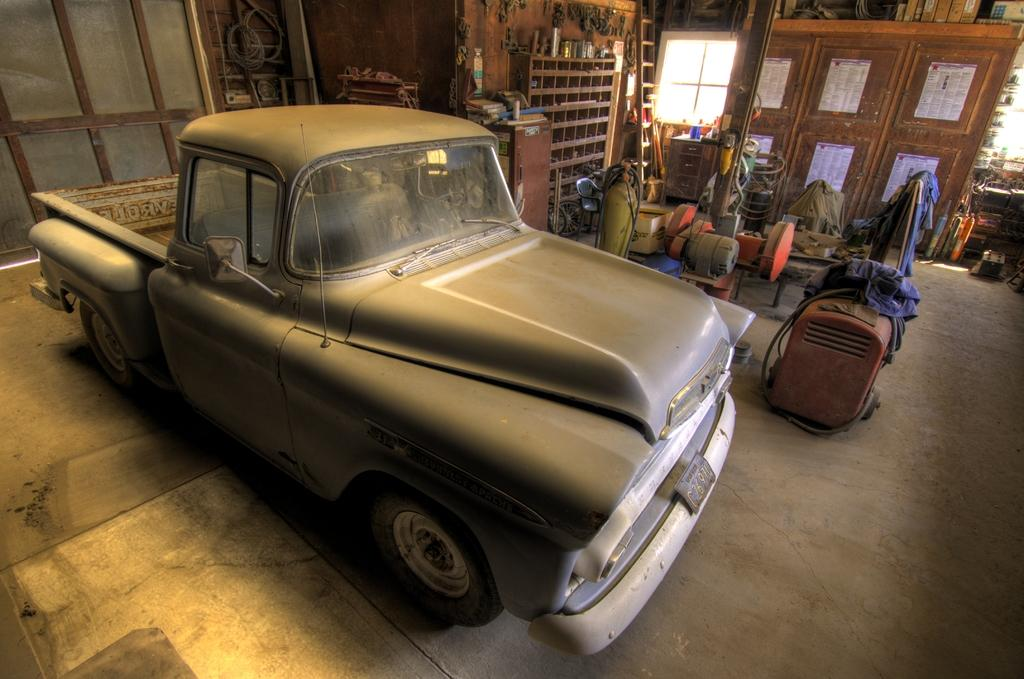What type of vehicle is in the image? The facts do not specify the type of vehicle in the image. What is the cylinder used for in the image? The facts do not specify the purpose of the cylinder in the image. What type of clothes are visible in the image? The facts do not specify the type of clothes in the image. What is the ladder used for in the image? The facts do not specify the purpose of the ladder in the image. What is on the desk in the image? The facts do not specify what is on the desk in the image. What objects are on the floor in the image? The facts do not specify the objects on the floor in the image. What can be seen through the window in the background of the image? The facts do not specify what can be seen through the window in the background of the image. What objects are visible in the background of the image? The facts do not specify the objects visible in the background of the image. How does the pickle contribute to the laughter in the image? There is no pickle or laughter present in the image. How does the wind affect the objects on the floor in the image? There is no mention of wind in the image, and therefore its effect on the objects on the floor cannot be determined. 